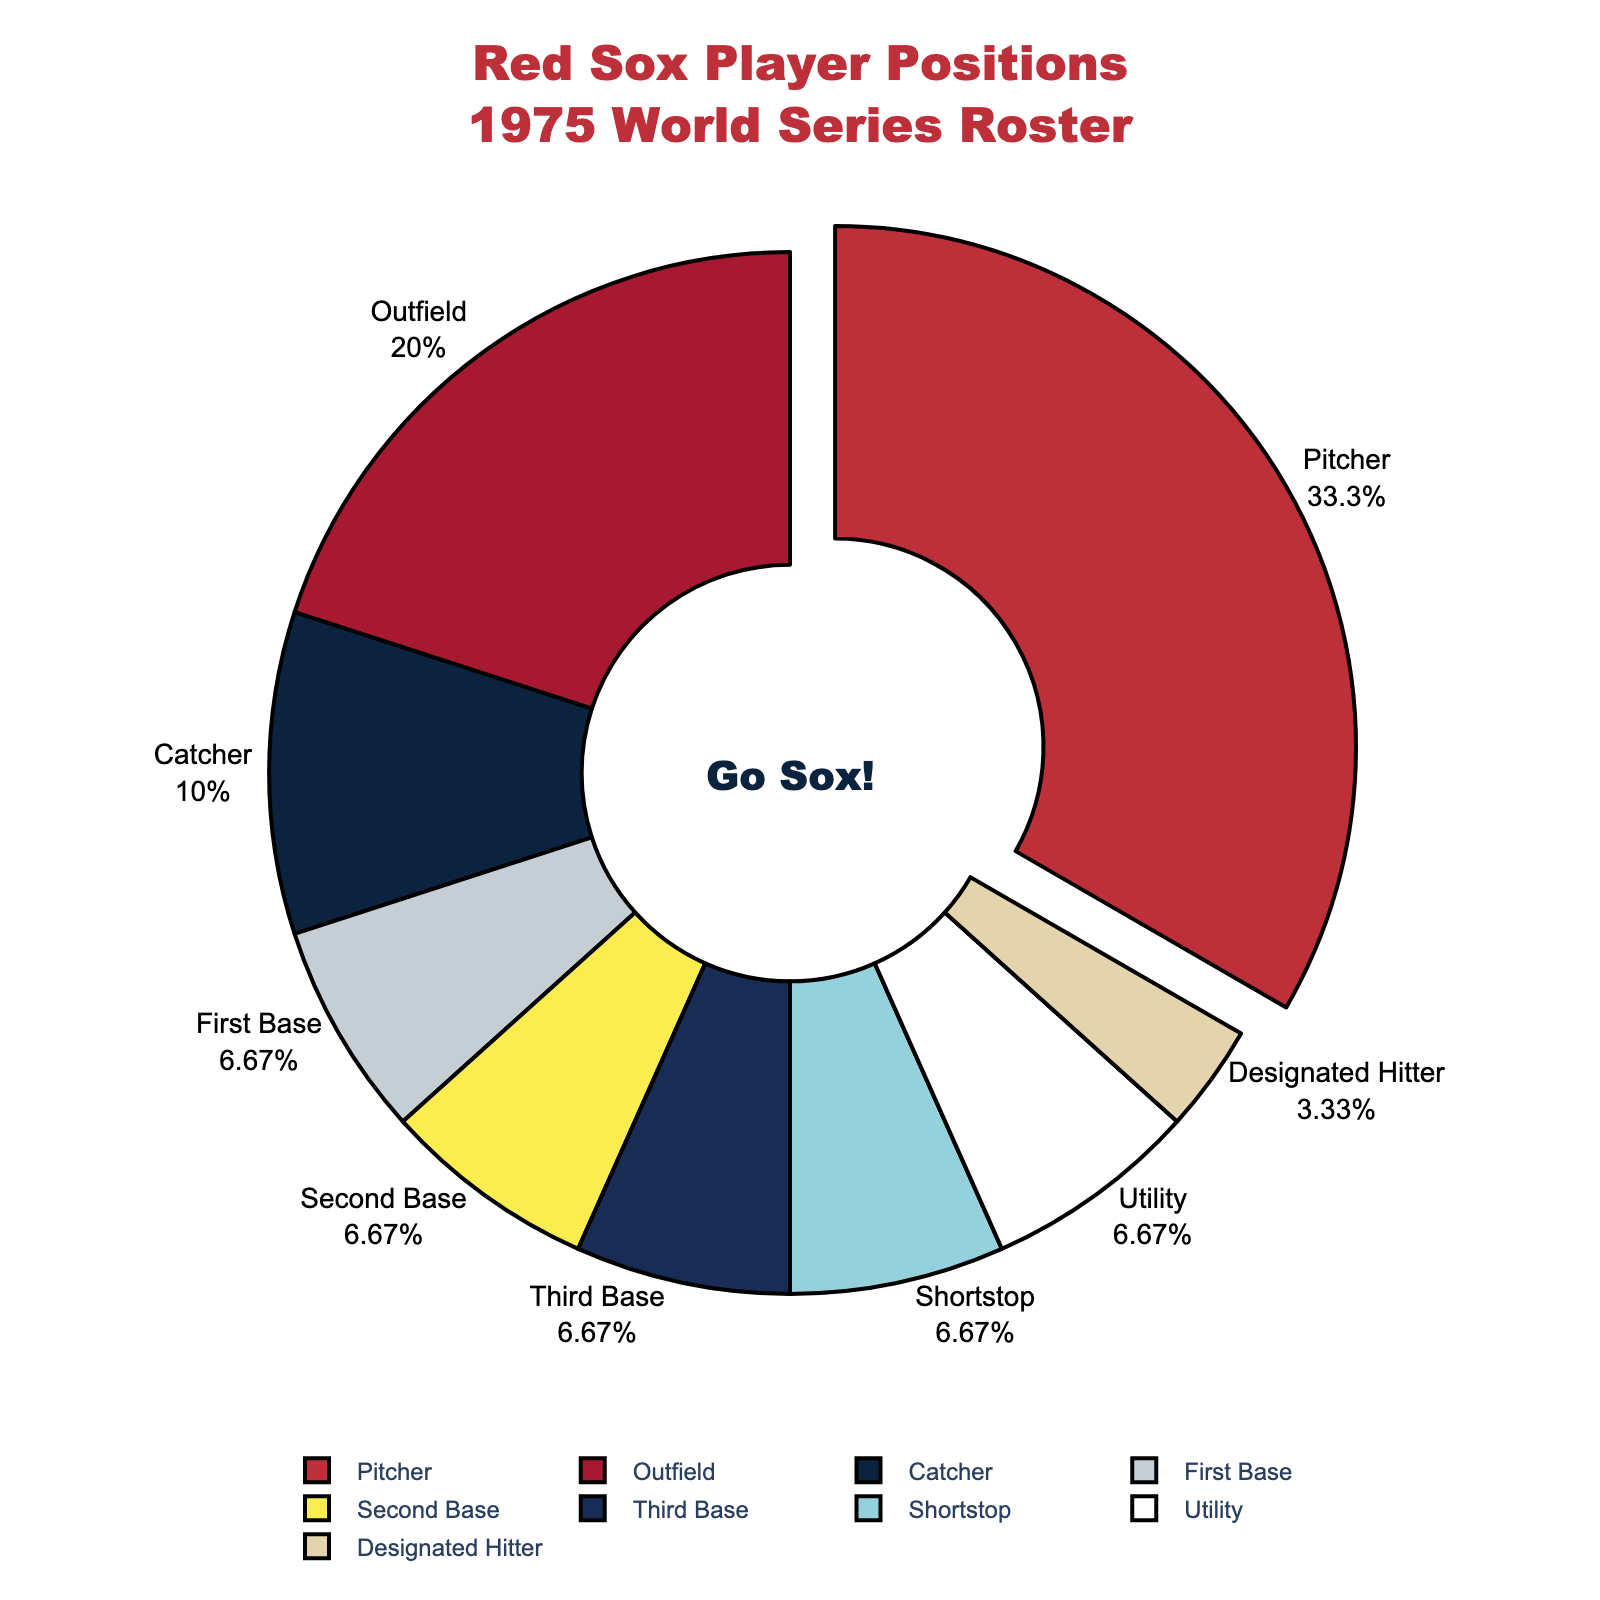Which player position has the largest proportion in the roster? The largest slice of the pie chart is labeled "Pitcher," indicating it has the highest proportion.
Answer: Pitcher What percentage of the roster do catchers make up? The pie chart shows percentages for each position. The slice for "Catcher" shows 10%, so Catchers make up 10% of the roster.
Answer: 10% How many positions have a count equal to 2? By inspecting the pie chart, we see that First Base, Second Base, Third Base, Shortstop, and Utility each have a count of 2.
Answer: 5 Does the number of outfielders exceed the combined count of infielders at First Base and Second Base? Outfielders are 6, while First Base and Second Base combined are 2+2=4. Since 6 > 4, the number of outfielders is indeed greater.
Answer: Yes By how much does the number of pitchers exceed the number of designated hitters? Pitchers number 10 while there is 1 Designated Hitter. The difference is 10 - 1 = 9.
Answer: 9 Which position slices are displayed in the color red? According to the color palette and visible colors in the chart, the slice for "Pitcher" is displayed in red.
Answer: Pitcher Is there an equal number of catchers and utility players? The pie chart indicates that both Catchers and Utility players have a count of 3 and 2 respectively.
Answer: No What is the combined proportion of Utility, First Base, and Second Base players on the roster? Utility (2), First Base (2), and Second Base (2) sum to 6 players, out of a total of 30. The proportion is (6/30) * 100% = 20%.
Answer: 20% Which player positions contribute to more than half the roster? The sum of Pitchers (10), Catchers (3), and Outfielders (6) is 19. Since this covers more than 15 players, more than half the roster consists of Pitchers, Catchers, and Outfielders combined.
Answer: Pitchers, Catchers, Outfielders 